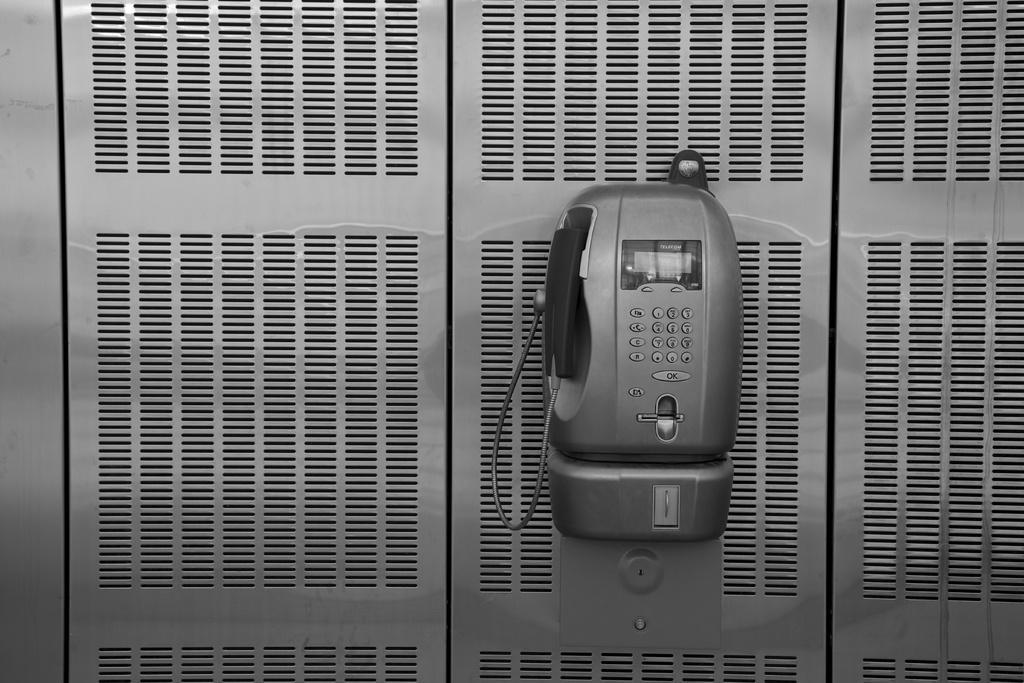Please provide a concise description of this image. In this picture we can see a telephone on a steel object and on the telephone there are buttons and on the left side of the telephone there is a cable. 